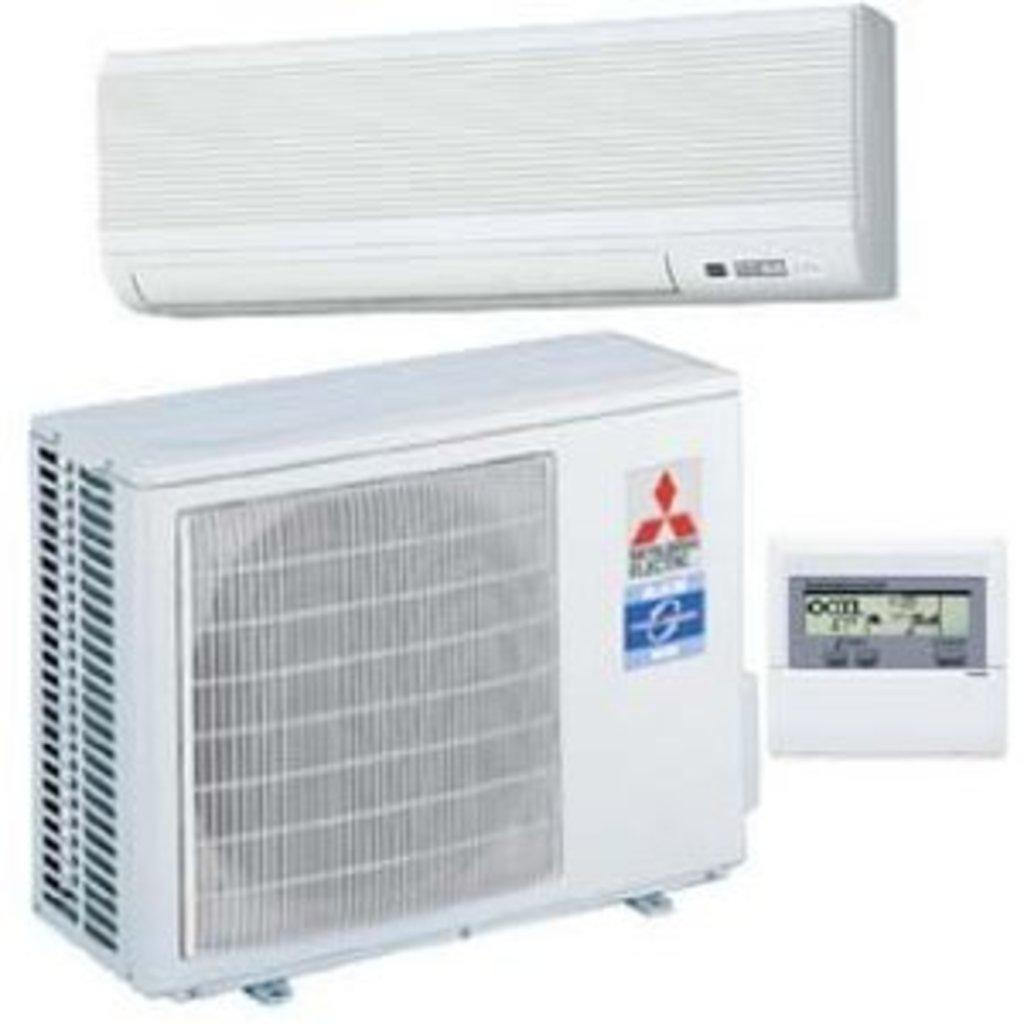What type of objects are present in the image? There are electronic devices in the image. Can you describe the color of the electronic devices? The electronic devices are white in color. What additional detail can be observed on the electronic devices? There are logos visible on the electronic devices. Is there any heat or action coming from the volcano in the image? There is no volcano present in the image; it features electronic devices. 